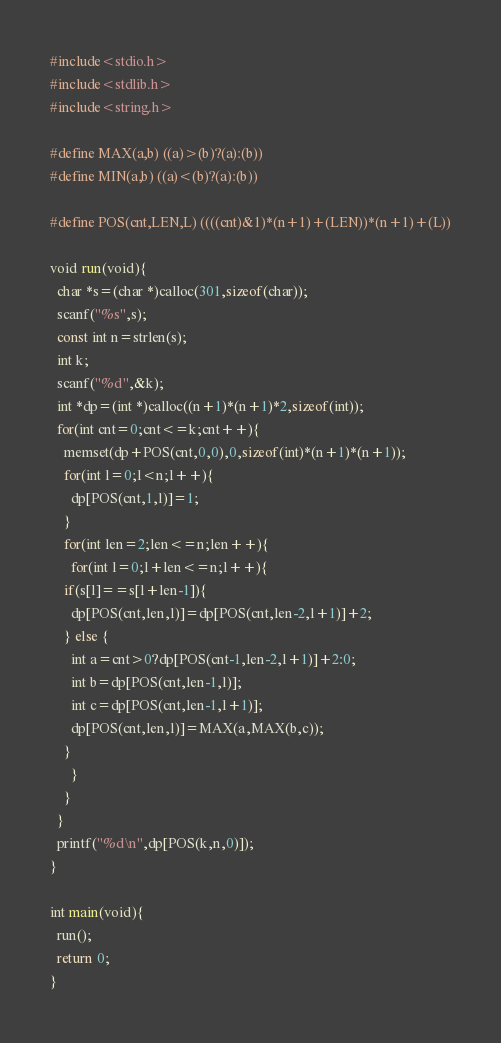Convert code to text. <code><loc_0><loc_0><loc_500><loc_500><_C_>#include<stdio.h>
#include<stdlib.h>
#include<string.h>

#define MAX(a,b) ((a)>(b)?(a):(b))
#define MIN(a,b) ((a)<(b)?(a):(b))

#define POS(cnt,LEN,L) ((((cnt)&1)*(n+1)+(LEN))*(n+1)+(L))

void run(void){
  char *s=(char *)calloc(301,sizeof(char));
  scanf("%s",s);
  const int n=strlen(s);
  int k;
  scanf("%d",&k);
  int *dp=(int *)calloc((n+1)*(n+1)*2,sizeof(int));
  for(int cnt=0;cnt<=k;cnt++){
    memset(dp+POS(cnt,0,0),0,sizeof(int)*(n+1)*(n+1));
    for(int l=0;l<n;l++){
      dp[POS(cnt,1,l)]=1;
    }
    for(int len=2;len<=n;len++){
      for(int l=0;l+len<=n;l++){
	if(s[l]==s[l+len-1]){
	  dp[POS(cnt,len,l)]=dp[POS(cnt,len-2,l+1)]+2;
	} else {
	  int a=cnt>0?dp[POS(cnt-1,len-2,l+1)]+2:0;
	  int b=dp[POS(cnt,len-1,l)];
	  int c=dp[POS(cnt,len-1,l+1)];
	  dp[POS(cnt,len,l)]=MAX(a,MAX(b,c));
	}
      }
    }
  }
  printf("%d\n",dp[POS(k,n,0)]);
}

int main(void){
  run();
  return 0;
}
</code> 